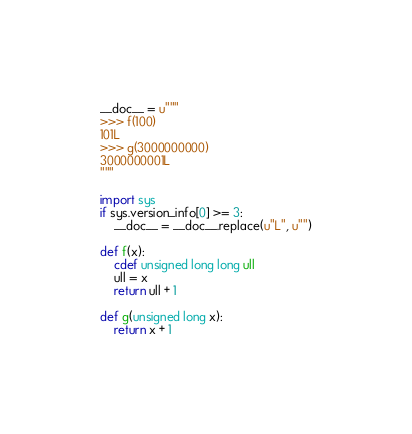Convert code to text. <code><loc_0><loc_0><loc_500><loc_500><_Cython_>__doc__ = u"""
>>> f(100)
101L
>>> g(3000000000)
3000000001L
"""

import sys
if sys.version_info[0] >= 3:
    __doc__ = __doc__.replace(u"L", u"")

def f(x):
    cdef unsigned long long ull
    ull = x
    return ull + 1

def g(unsigned long x):
    return x + 1
</code> 